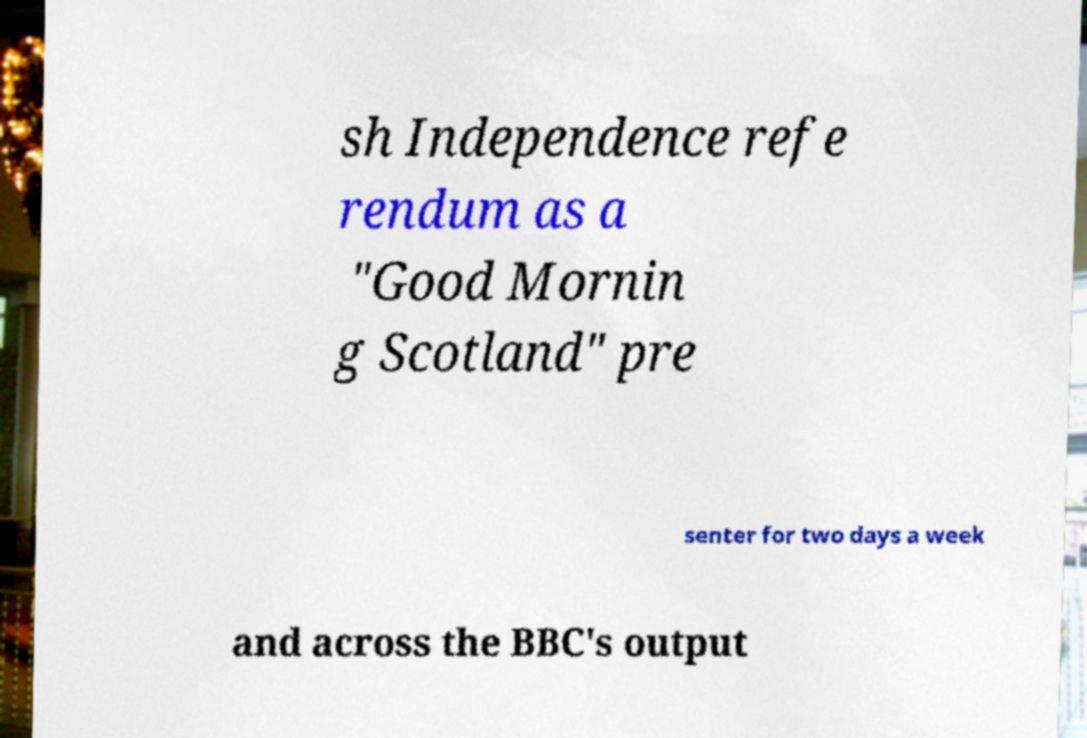What messages or text are displayed in this image? I need them in a readable, typed format. sh Independence refe rendum as a "Good Mornin g Scotland" pre senter for two days a week and across the BBC's output 